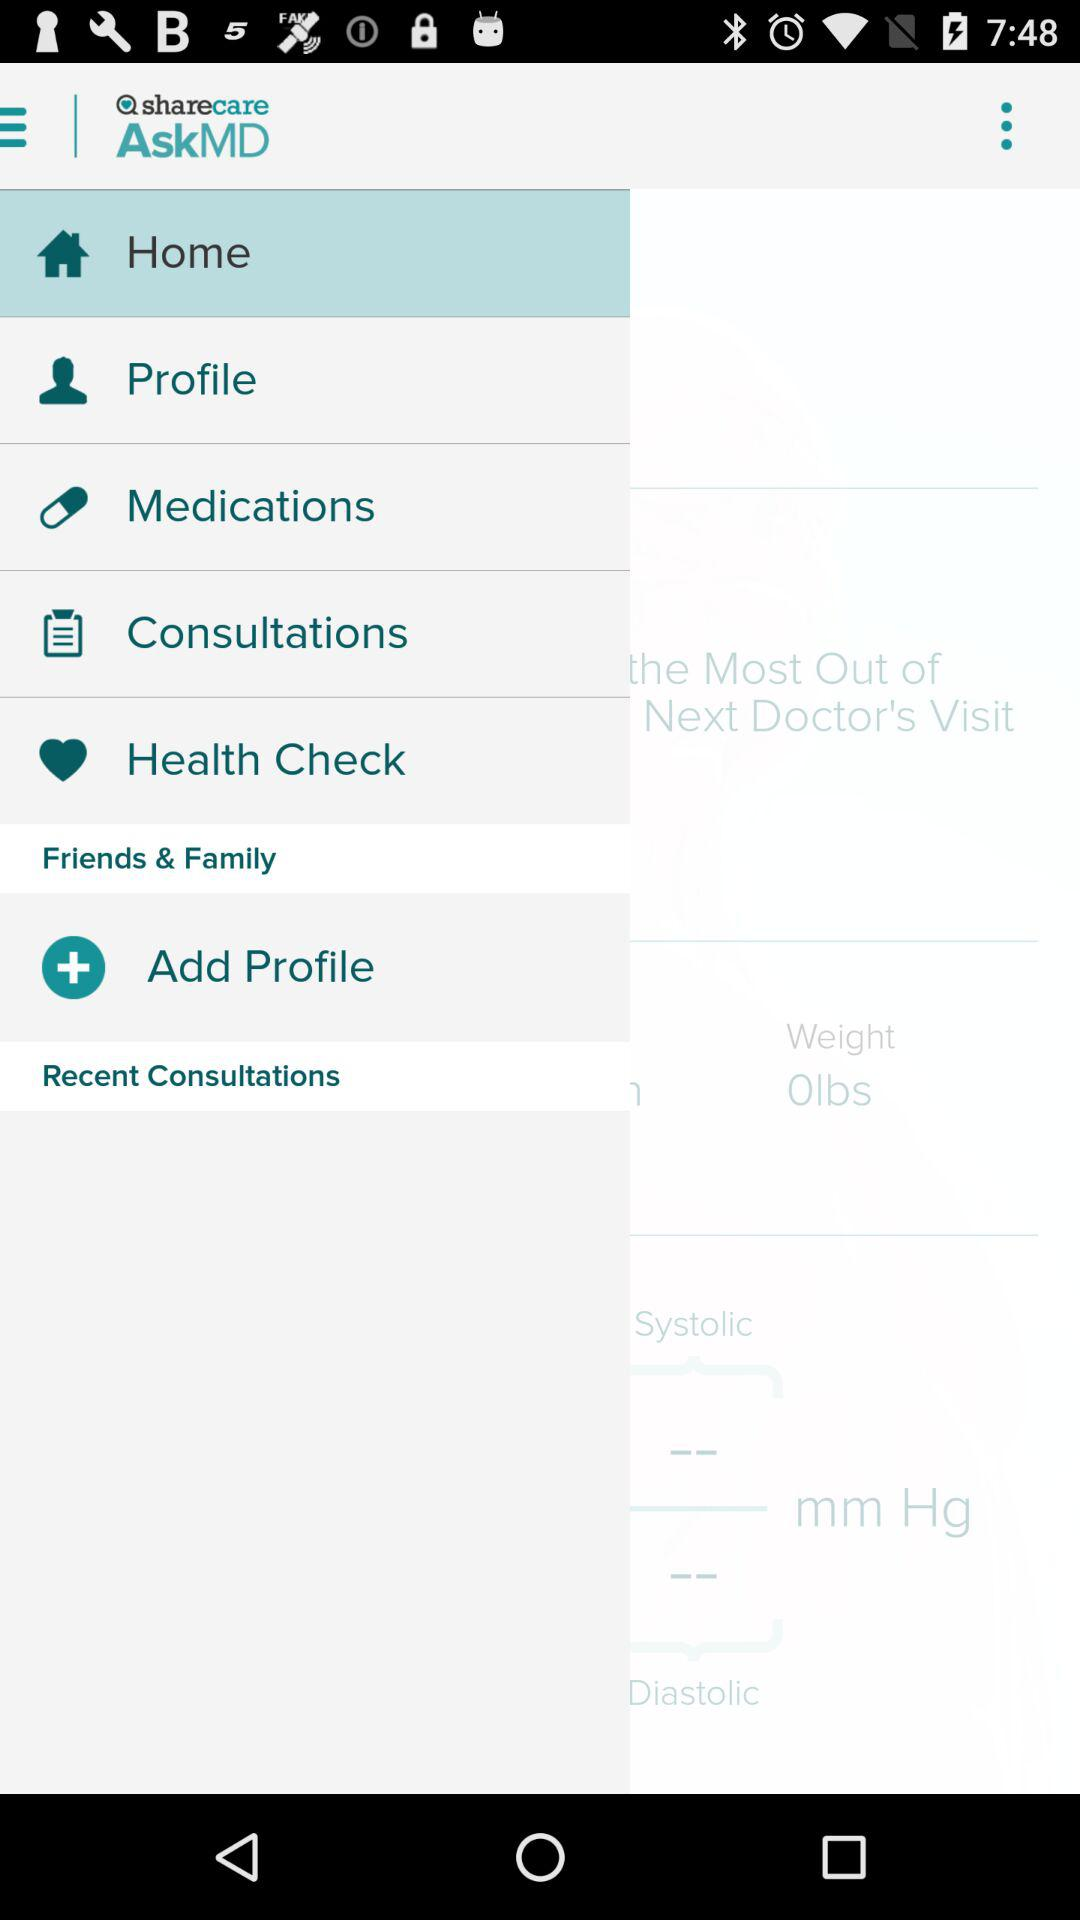What is the application name? The application name is "AskMD". 